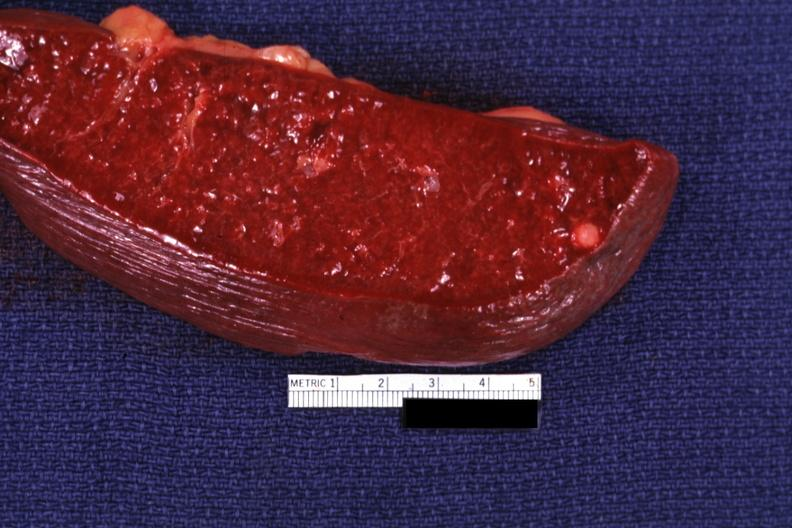s spleen present?
Answer the question using a single word or phrase. Yes 